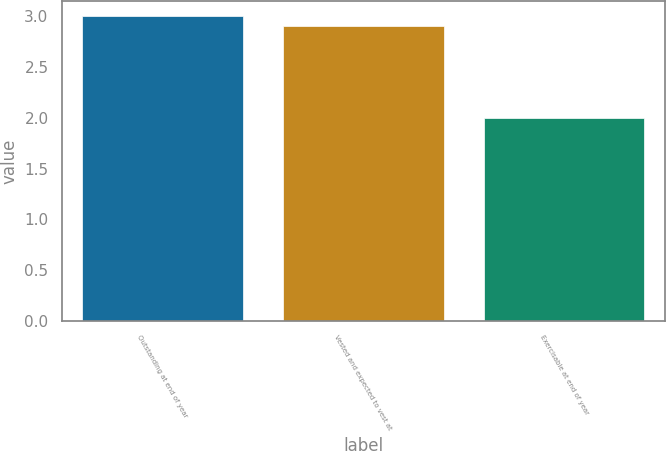Convert chart. <chart><loc_0><loc_0><loc_500><loc_500><bar_chart><fcel>Outstanding at end of year<fcel>Vested and expected to vest at<fcel>Exercisable at end of year<nl><fcel>3<fcel>2.9<fcel>2<nl></chart> 